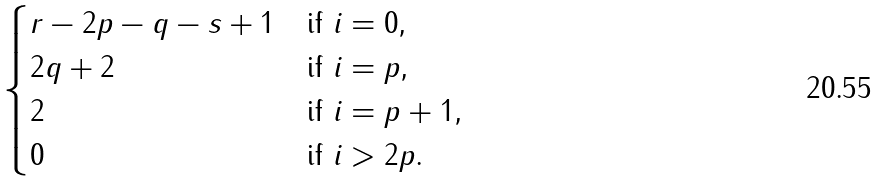Convert formula to latex. <formula><loc_0><loc_0><loc_500><loc_500>\begin{cases} r - 2 p - q - s + 1 & \text {if $i = 0$,} \\ 2 q + 2 & \text {if $i = p$,} \\ 2 & \text {if $i = p+1$,} \\ 0 & \text {if $i > 2p$.} \end{cases}</formula> 